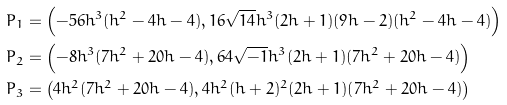Convert formula to latex. <formula><loc_0><loc_0><loc_500><loc_500>P _ { 1 } & = \left ( - 5 6 h ^ { 3 } ( h ^ { 2 } - 4 h - 4 ) , 1 6 \sqrt { 1 4 } h ^ { 3 } ( 2 h + 1 ) ( 9 h - 2 ) ( h ^ { 2 } - 4 h - 4 ) \right ) \\ P _ { 2 } & = \left ( - 8 h ^ { 3 } ( 7 h ^ { 2 } + 2 0 h - 4 ) , 6 4 \sqrt { - 1 } h ^ { 3 } ( 2 h + 1 ) ( 7 h ^ { 2 } + 2 0 h - 4 ) \right ) \\ P _ { 3 } & = \left ( 4 h ^ { 2 } ( 7 h ^ { 2 } + 2 0 h - 4 ) , 4 h ^ { 2 } ( h + 2 ) ^ { 2 } ( 2 h + 1 ) ( 7 h ^ { 2 } + 2 0 h - 4 ) \right )</formula> 